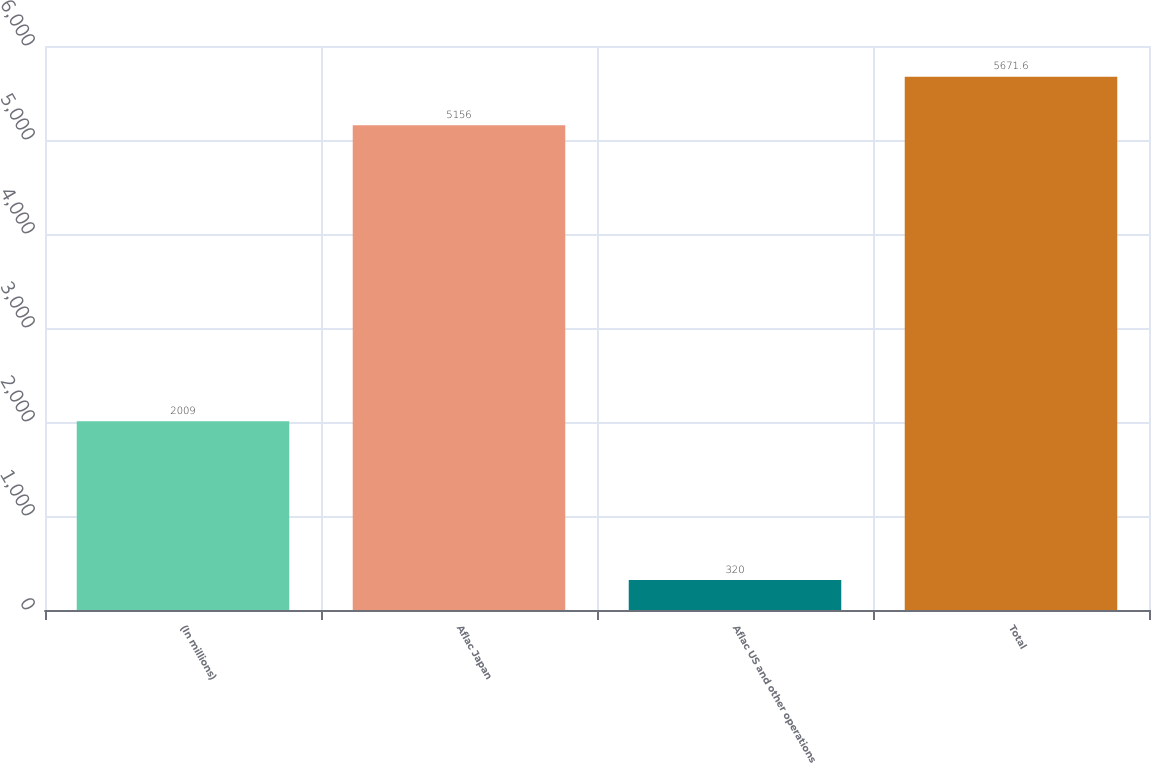<chart> <loc_0><loc_0><loc_500><loc_500><bar_chart><fcel>(In millions)<fcel>Aflac Japan<fcel>Aflac US and other operations<fcel>Total<nl><fcel>2009<fcel>5156<fcel>320<fcel>5671.6<nl></chart> 